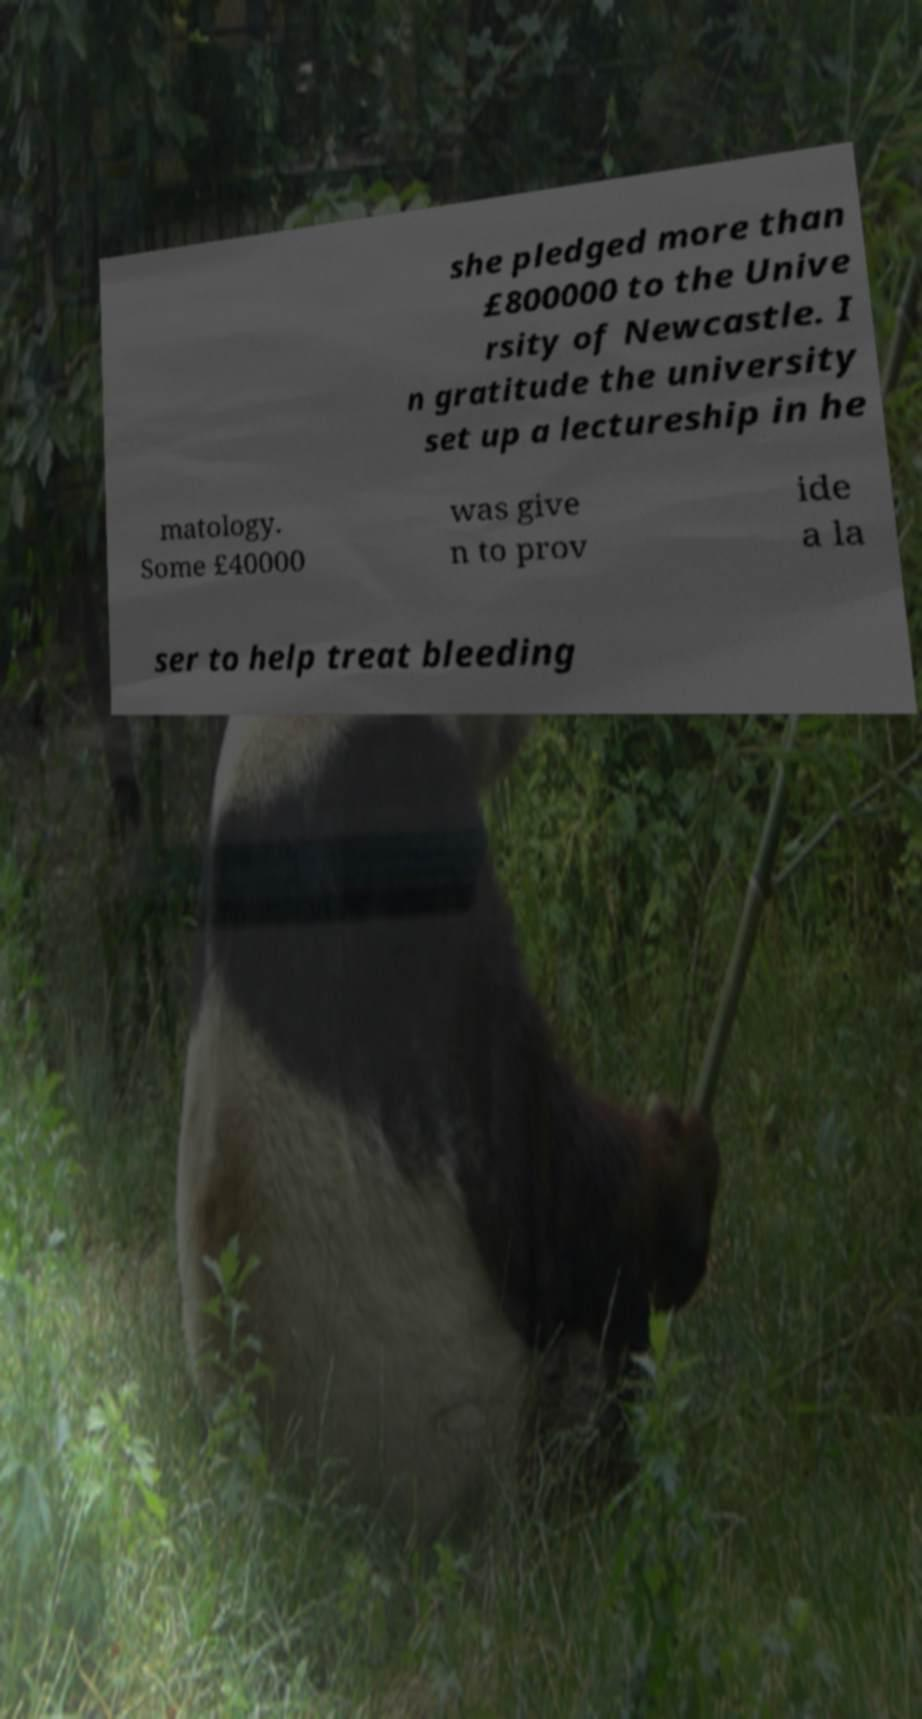Please read and relay the text visible in this image. What does it say? she pledged more than £800000 to the Unive rsity of Newcastle. I n gratitude the university set up a lectureship in he matology. Some £40000 was give n to prov ide a la ser to help treat bleeding 